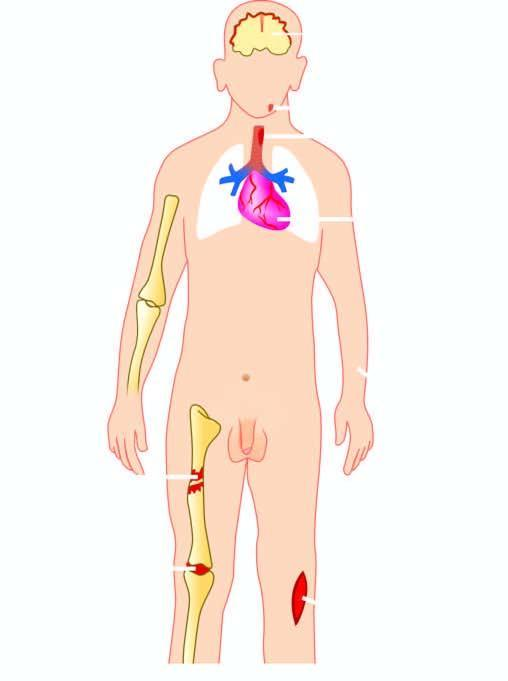how is suppurative diseases caused?
Answer the question using a single word or phrase. By staphylococcus aureus 